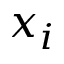Convert formula to latex. <formula><loc_0><loc_0><loc_500><loc_500>x _ { i }</formula> 